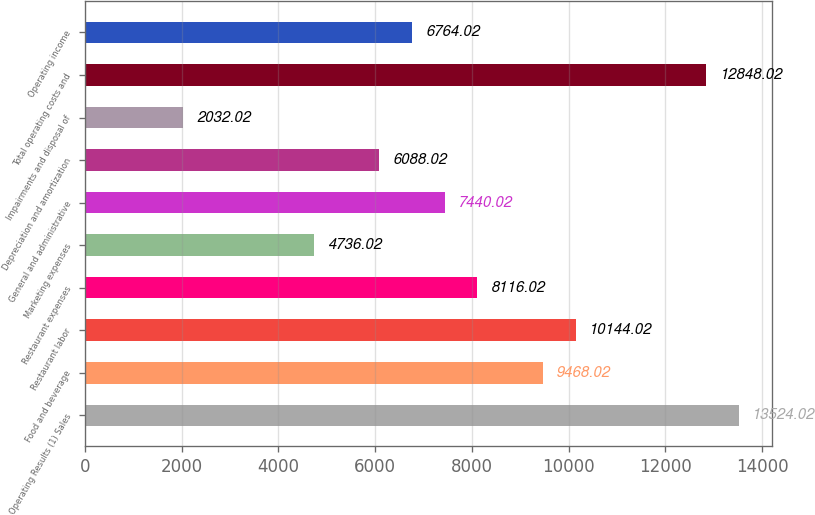<chart> <loc_0><loc_0><loc_500><loc_500><bar_chart><fcel>Operating Results (1) Sales<fcel>Food and beverage<fcel>Restaurant labor<fcel>Restaurant expenses<fcel>Marketing expenses<fcel>General and administrative<fcel>Depreciation and amortization<fcel>Impairments and disposal of<fcel>Total operating costs and<fcel>Operating income<nl><fcel>13524<fcel>9468.02<fcel>10144<fcel>8116.02<fcel>4736.02<fcel>7440.02<fcel>6088.02<fcel>2032.02<fcel>12848<fcel>6764.02<nl></chart> 